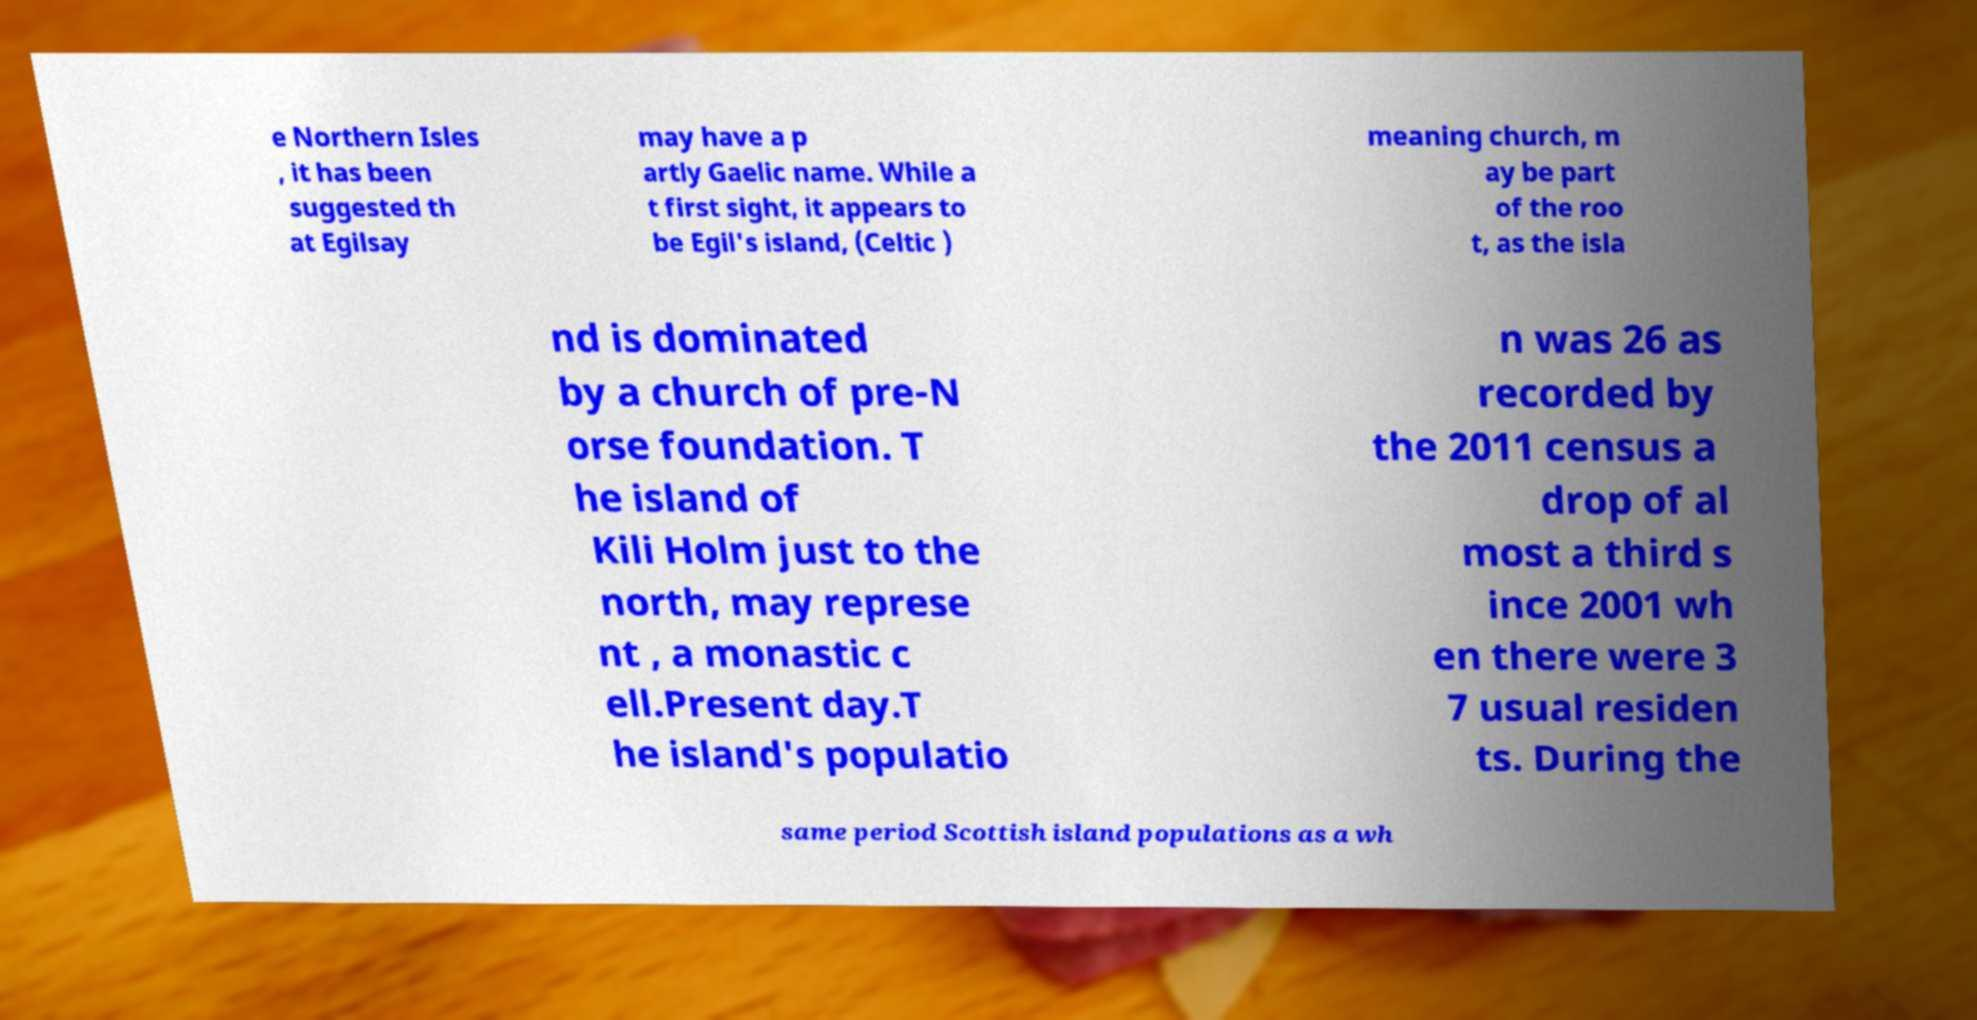Can you accurately transcribe the text from the provided image for me? e Northern Isles , it has been suggested th at Egilsay may have a p artly Gaelic name. While a t first sight, it appears to be Egil's island, (Celtic ) meaning church, m ay be part of the roo t, as the isla nd is dominated by a church of pre-N orse foundation. T he island of Kili Holm just to the north, may represe nt , a monastic c ell.Present day.T he island's populatio n was 26 as recorded by the 2011 census a drop of al most a third s ince 2001 wh en there were 3 7 usual residen ts. During the same period Scottish island populations as a wh 